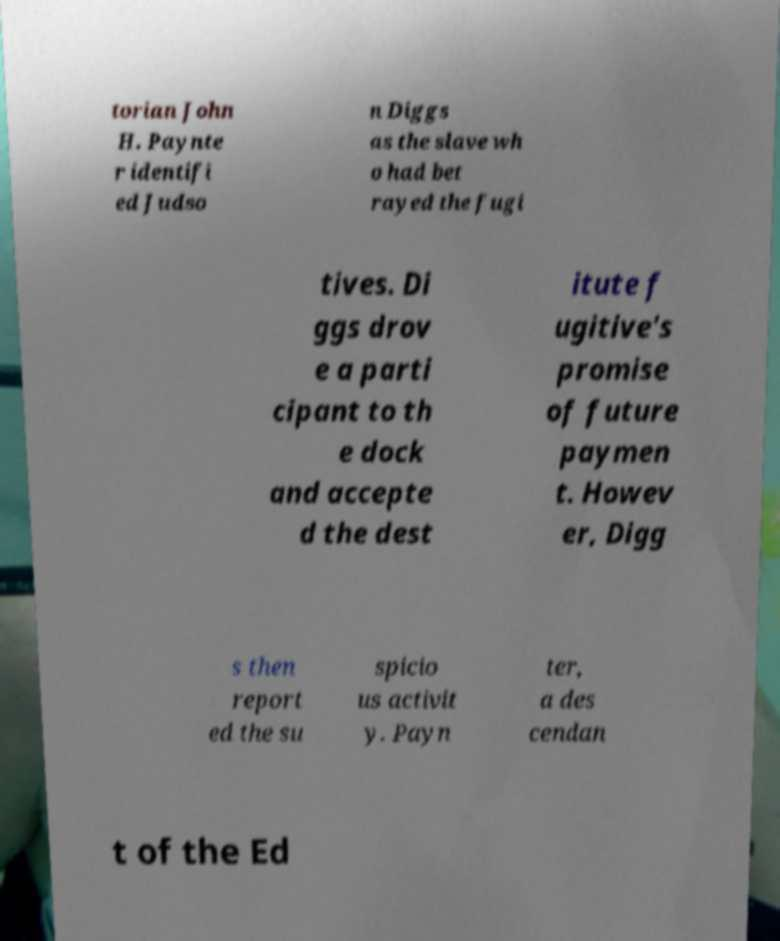For documentation purposes, I need the text within this image transcribed. Could you provide that? torian John H. Paynte r identifi ed Judso n Diggs as the slave wh o had bet rayed the fugi tives. Di ggs drov e a parti cipant to th e dock and accepte d the dest itute f ugitive's promise of future paymen t. Howev er, Digg s then report ed the su spicio us activit y. Payn ter, a des cendan t of the Ed 